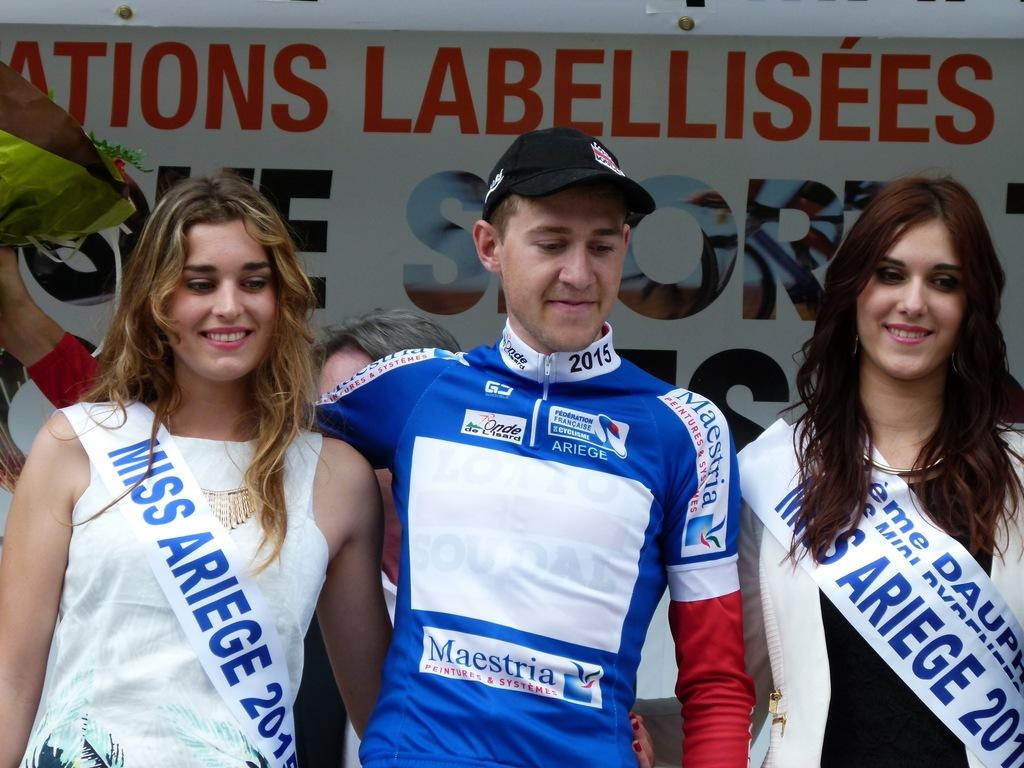Provide a one-sentence caption for the provided image. The racer celebrates with two former Miss Ariege. 